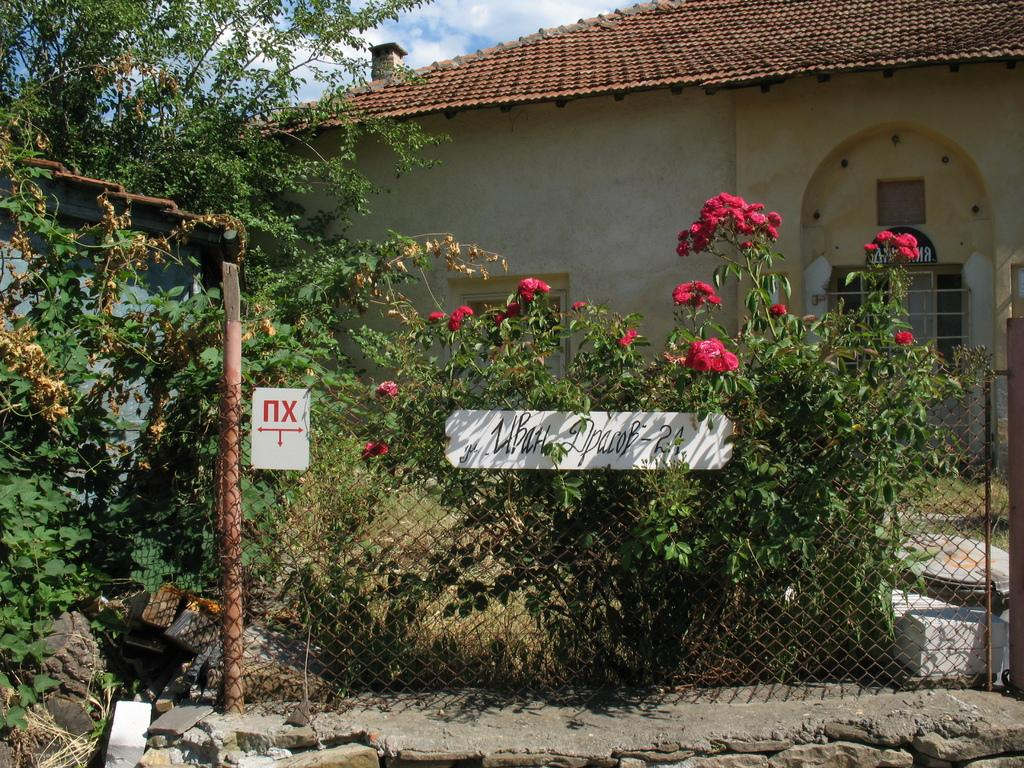What type of fencing is visible in the image? There is a black color fencing grill in the image. What color are the flower plants in the image? The flower plants in the image are red color. What structure can be seen in the background of the image? There is a shed house in the background of the image. What type of cloth is draped over the shed house in the image? There is no cloth draped over the shed house in the image; it is a shed house with no additional coverings. Are there any stockings hanging from the fencing grill in the image? There are no stockings present in the image; it features a black color fencing grill and red color flower plants. 